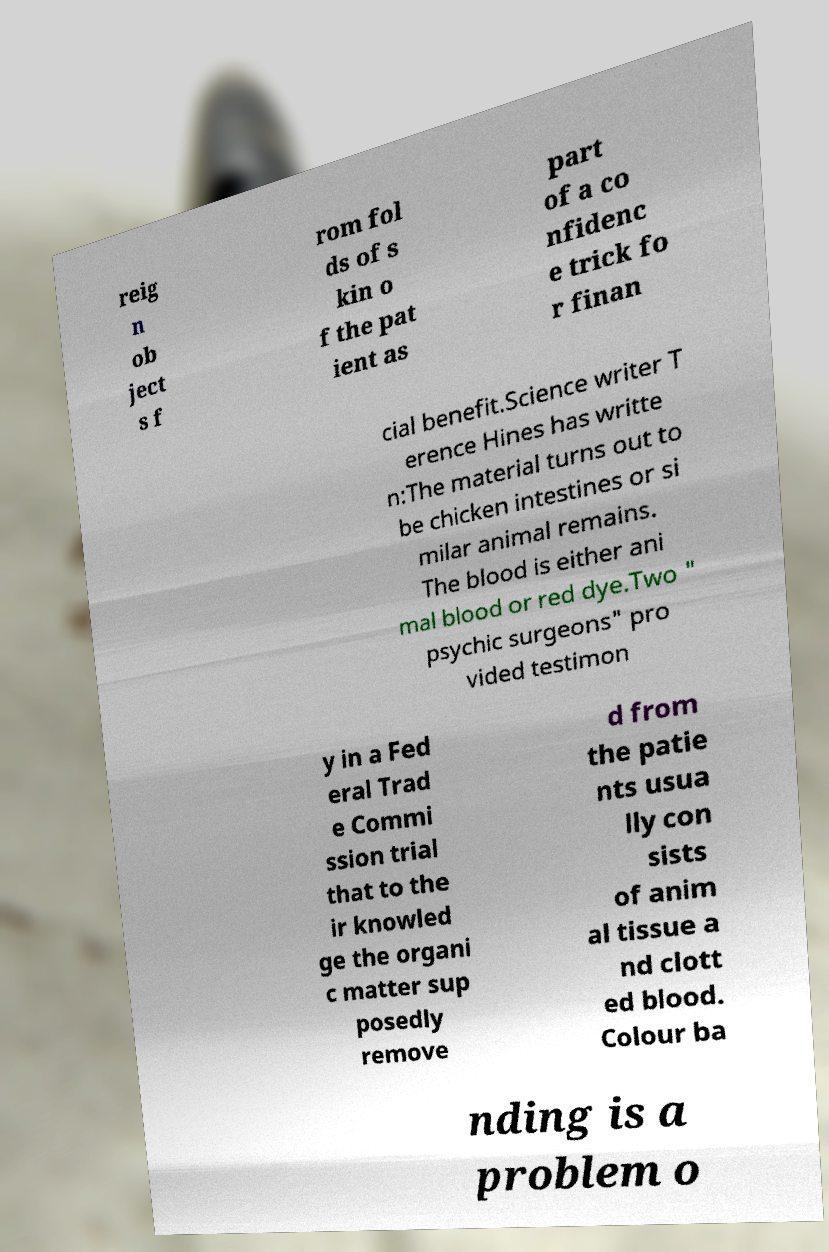Please read and relay the text visible in this image. What does it say? reig n ob ject s f rom fol ds of s kin o f the pat ient as part of a co nfidenc e trick fo r finan cial benefit.Science writer T erence Hines has writte n:The material turns out to be chicken intestines or si milar animal remains. The blood is either ani mal blood or red dye.Two " psychic surgeons" pro vided testimon y in a Fed eral Trad e Commi ssion trial that to the ir knowled ge the organi c matter sup posedly remove d from the patie nts usua lly con sists of anim al tissue a nd clott ed blood. Colour ba nding is a problem o 